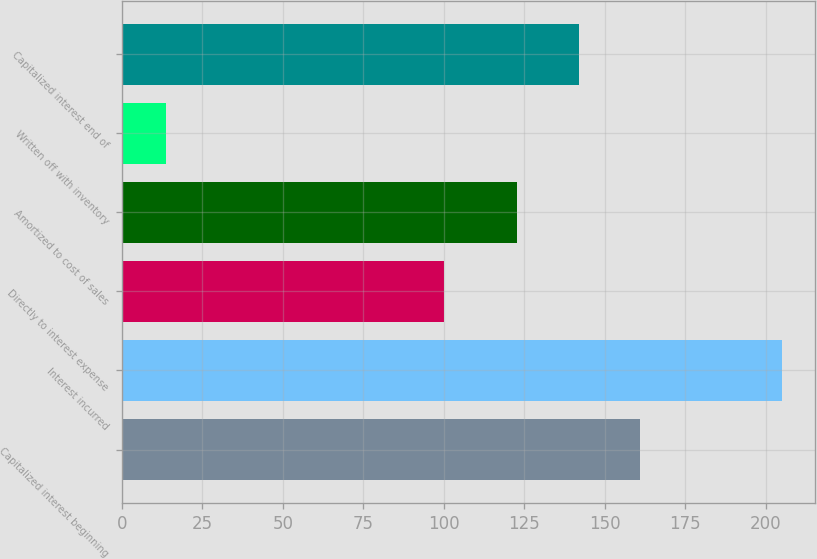<chart> <loc_0><loc_0><loc_500><loc_500><bar_chart><fcel>Capitalized interest beginning<fcel>Interest incurred<fcel>Directly to interest expense<fcel>Amortized to cost of sales<fcel>Written off with inventory<fcel>Capitalized interest end of<nl><fcel>161.04<fcel>205<fcel>100.2<fcel>122.8<fcel>13.8<fcel>141.92<nl></chart> 